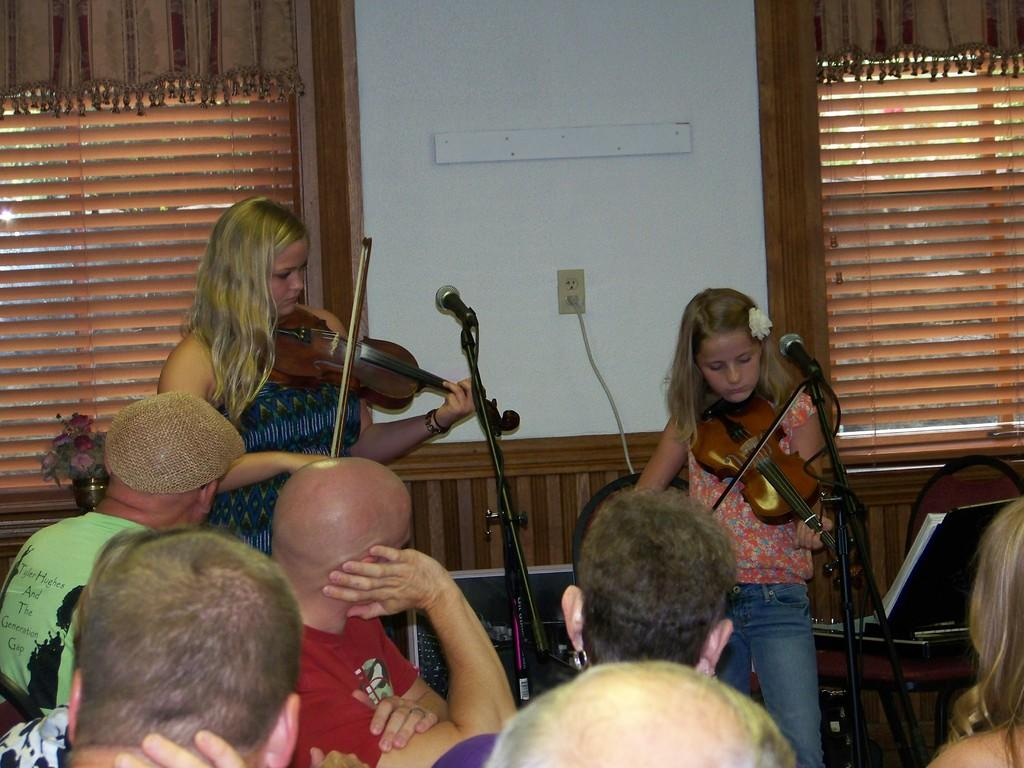What are the two girls doing in the image? The two girls are playing violin in the image. What can be seen behind the girls? They are in front of a microphone. What is visible near the window in the image? There is a window with a curtain in the image. Who is present in the audience? There are people in the audience. What decorative item can be seen in the image? There is a flower vase in the image. What object is placed on a table? There is a box on a table in the image. What type of brass instrument is the girl playing in the image? The girls are playing violins, which are string instruments, not brass instruments. What advice can be given to the girl playing the violin in the image? There is no need to give advice to the girl in the image, as we are only observing and describing the scene. 